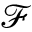<formula> <loc_0><loc_0><loc_500><loc_500>\mathcal { F }</formula> 